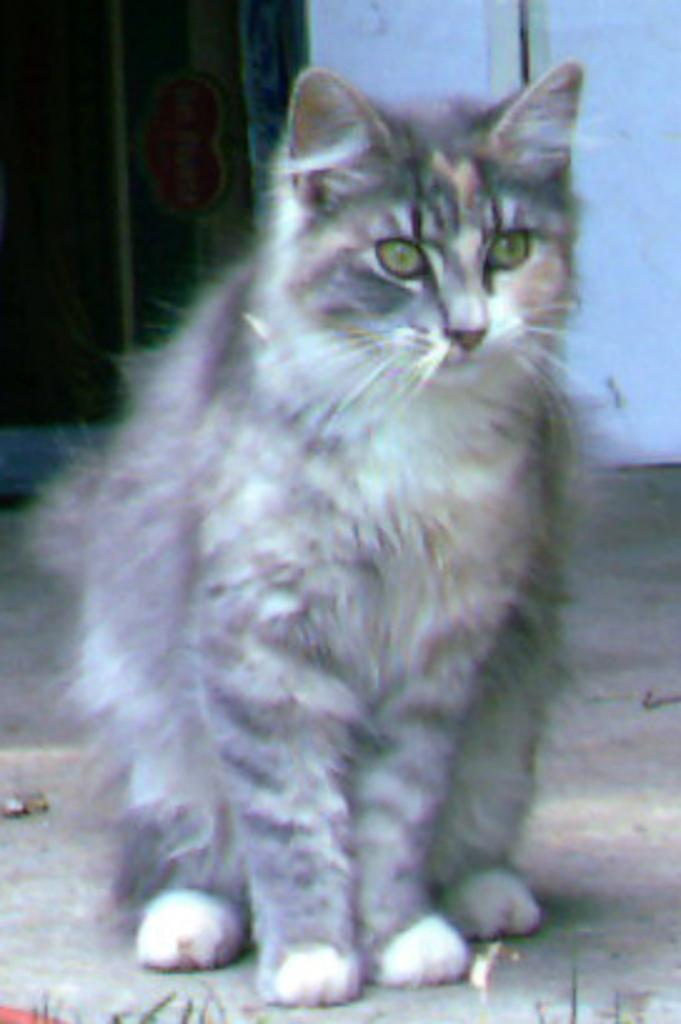What type of animal can be seen in the image? There is a cat in the image. What color is the wall behind the cat? The wall is white in the image. What architectural feature is present in the image? There is a door in the image. What type of screw can be seen holding the door in the image? There is no screw visible in the image; the door's presence is mentioned, but no specific details about its construction are provided. 